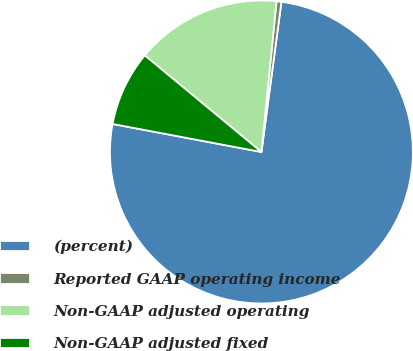Convert chart to OTSL. <chart><loc_0><loc_0><loc_500><loc_500><pie_chart><fcel>(percent)<fcel>Reported GAAP operating income<fcel>Non-GAAP adjusted operating<fcel>Non-GAAP adjusted fixed<nl><fcel>75.85%<fcel>0.52%<fcel>15.58%<fcel>8.05%<nl></chart> 